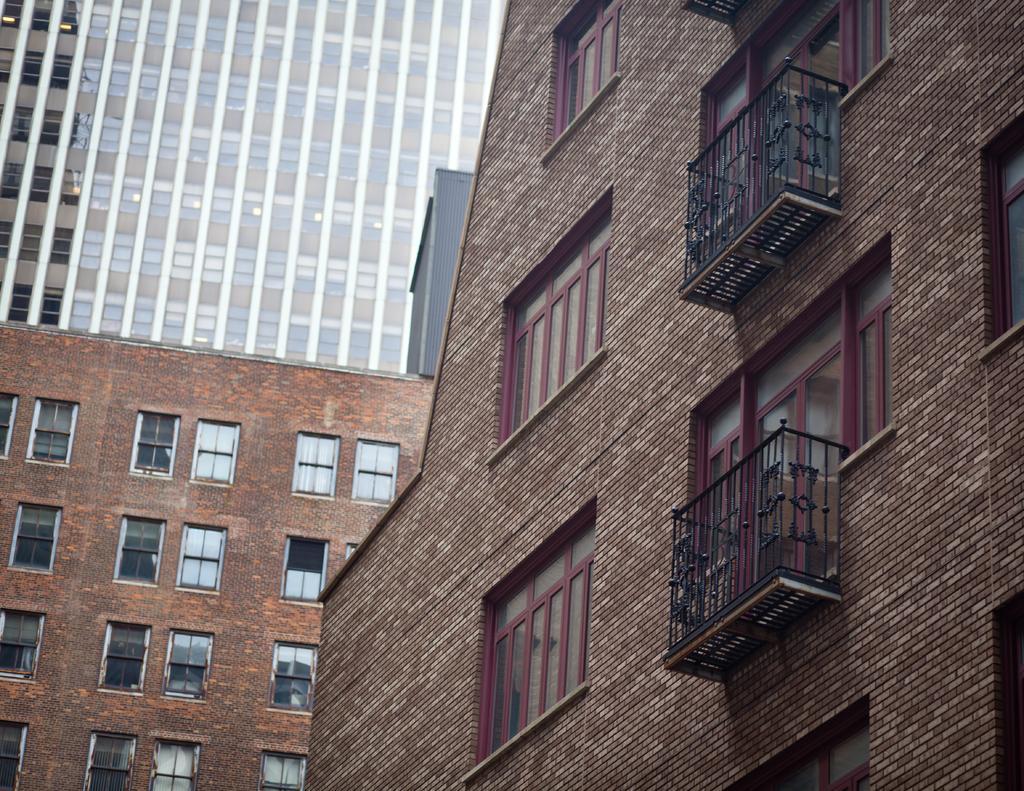In one or two sentences, can you explain what this image depicts? In the image we can see some buildings. 